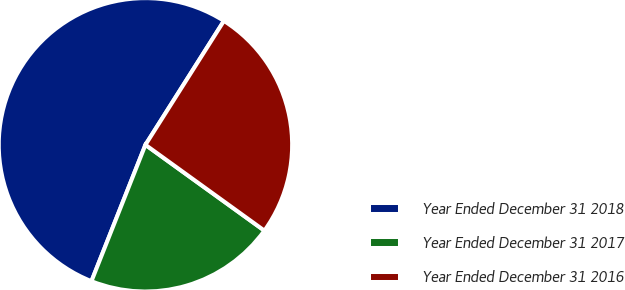<chart> <loc_0><loc_0><loc_500><loc_500><pie_chart><fcel>Year Ended December 31 2018<fcel>Year Ended December 31 2017<fcel>Year Ended December 31 2016<nl><fcel>52.98%<fcel>21.05%<fcel>25.96%<nl></chart> 